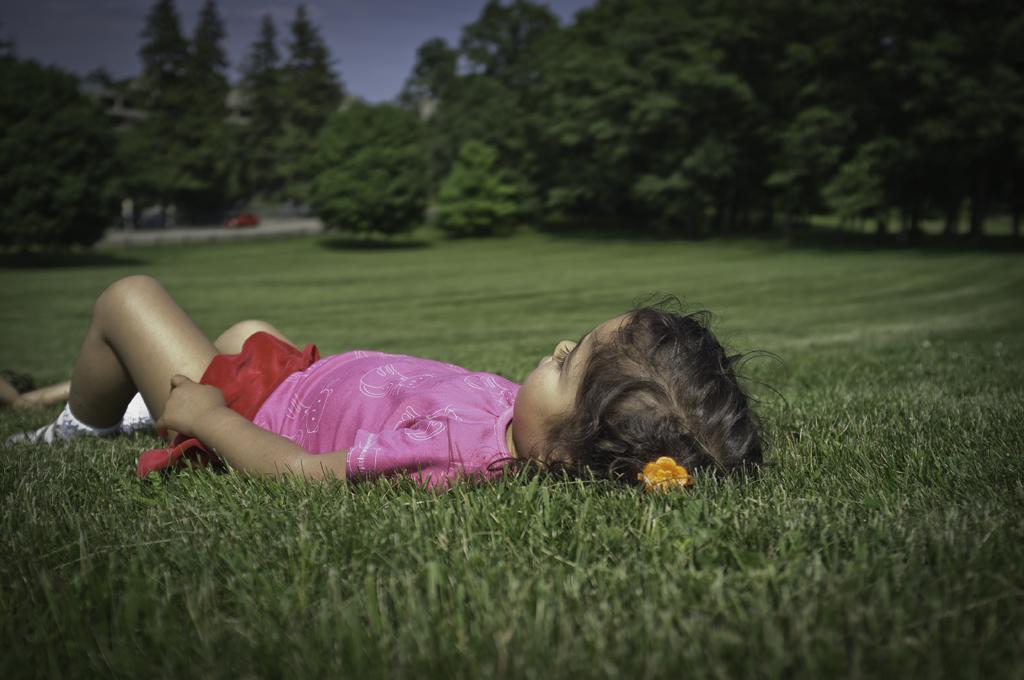In one or two sentences, can you explain what this image depicts? In the foreground of this image, there is a girl lying on the grass. In the background, there are trees, a vehicle on the road and the sky. 